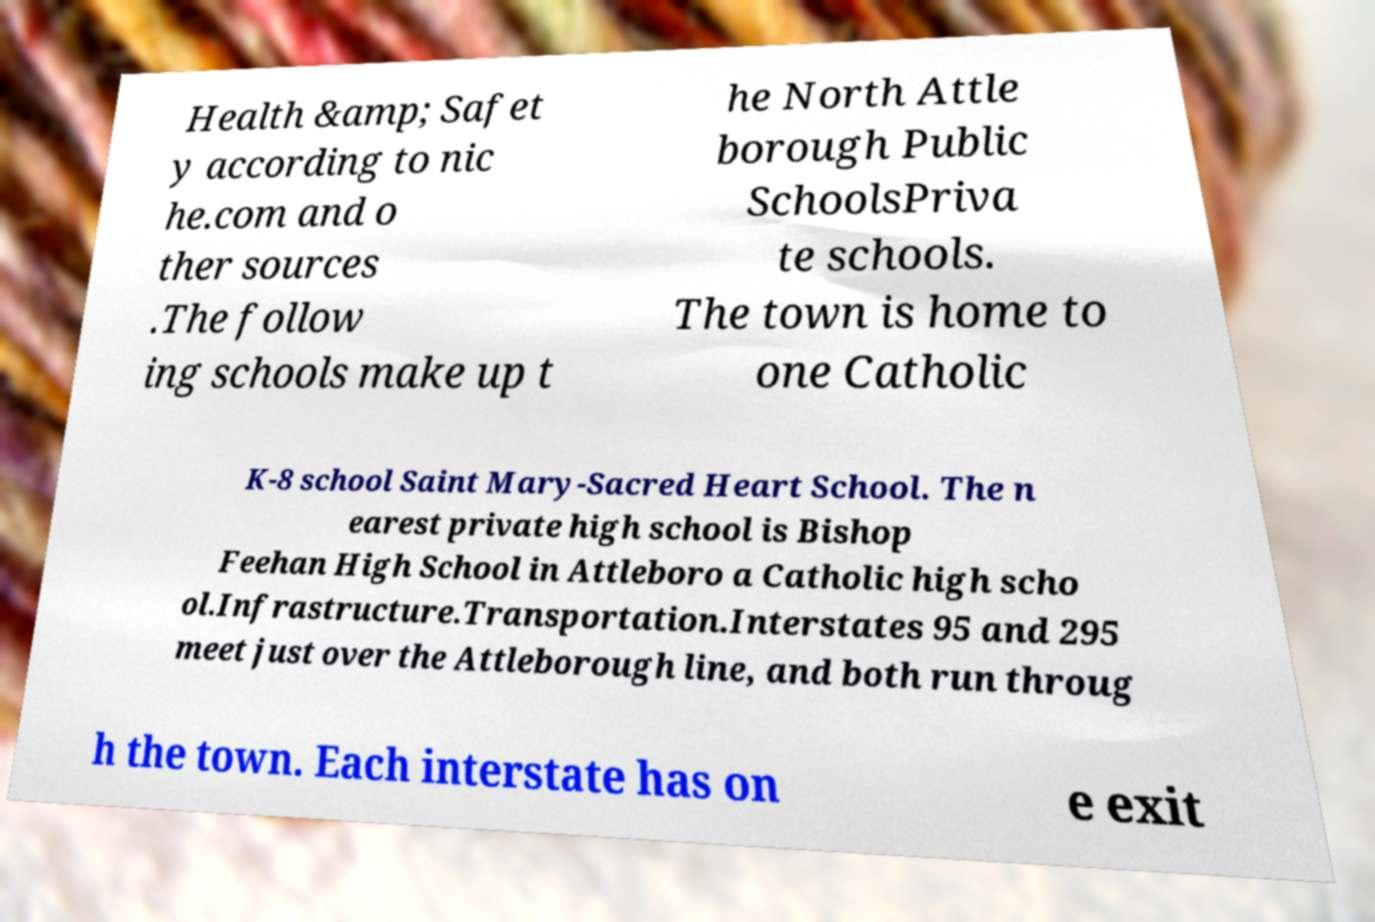Can you read and provide the text displayed in the image?This photo seems to have some interesting text. Can you extract and type it out for me? Health &amp; Safet y according to nic he.com and o ther sources .The follow ing schools make up t he North Attle borough Public SchoolsPriva te schools. The town is home to one Catholic K-8 school Saint Mary-Sacred Heart School. The n earest private high school is Bishop Feehan High School in Attleboro a Catholic high scho ol.Infrastructure.Transportation.Interstates 95 and 295 meet just over the Attleborough line, and both run throug h the town. Each interstate has on e exit 